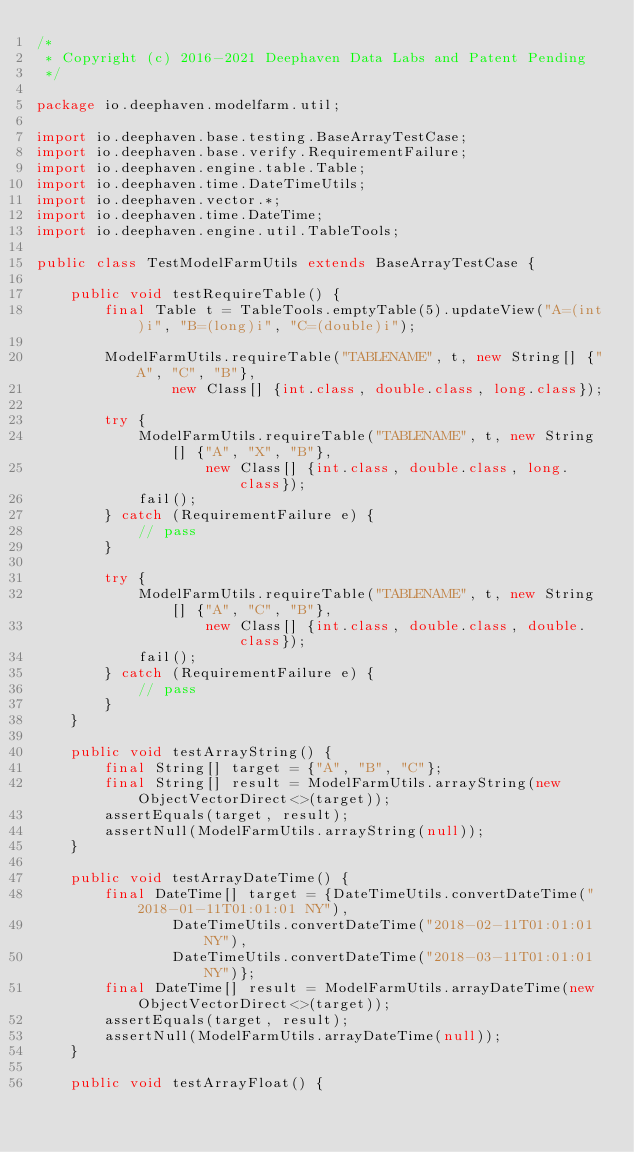Convert code to text. <code><loc_0><loc_0><loc_500><loc_500><_Java_>/*
 * Copyright (c) 2016-2021 Deephaven Data Labs and Patent Pending
 */

package io.deephaven.modelfarm.util;

import io.deephaven.base.testing.BaseArrayTestCase;
import io.deephaven.base.verify.RequirementFailure;
import io.deephaven.engine.table.Table;
import io.deephaven.time.DateTimeUtils;
import io.deephaven.vector.*;
import io.deephaven.time.DateTime;
import io.deephaven.engine.util.TableTools;

public class TestModelFarmUtils extends BaseArrayTestCase {

    public void testRequireTable() {
        final Table t = TableTools.emptyTable(5).updateView("A=(int)i", "B=(long)i", "C=(double)i");

        ModelFarmUtils.requireTable("TABLENAME", t, new String[] {"A", "C", "B"},
                new Class[] {int.class, double.class, long.class});

        try {
            ModelFarmUtils.requireTable("TABLENAME", t, new String[] {"A", "X", "B"},
                    new Class[] {int.class, double.class, long.class});
            fail();
        } catch (RequirementFailure e) {
            // pass
        }

        try {
            ModelFarmUtils.requireTable("TABLENAME", t, new String[] {"A", "C", "B"},
                    new Class[] {int.class, double.class, double.class});
            fail();
        } catch (RequirementFailure e) {
            // pass
        }
    }

    public void testArrayString() {
        final String[] target = {"A", "B", "C"};
        final String[] result = ModelFarmUtils.arrayString(new ObjectVectorDirect<>(target));
        assertEquals(target, result);
        assertNull(ModelFarmUtils.arrayString(null));
    }

    public void testArrayDateTime() {
        final DateTime[] target = {DateTimeUtils.convertDateTime("2018-01-11T01:01:01 NY"),
                DateTimeUtils.convertDateTime("2018-02-11T01:01:01 NY"),
                DateTimeUtils.convertDateTime("2018-03-11T01:01:01 NY")};
        final DateTime[] result = ModelFarmUtils.arrayDateTime(new ObjectVectorDirect<>(target));
        assertEquals(target, result);
        assertNull(ModelFarmUtils.arrayDateTime(null));
    }

    public void testArrayFloat() {</code> 